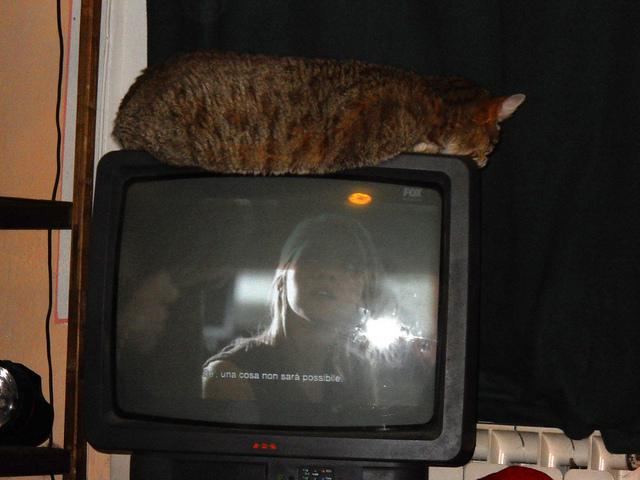Why is the cat sitting here?

Choices:
A) to hunt
B) to eat
C) warmth
D) to hide warmth 